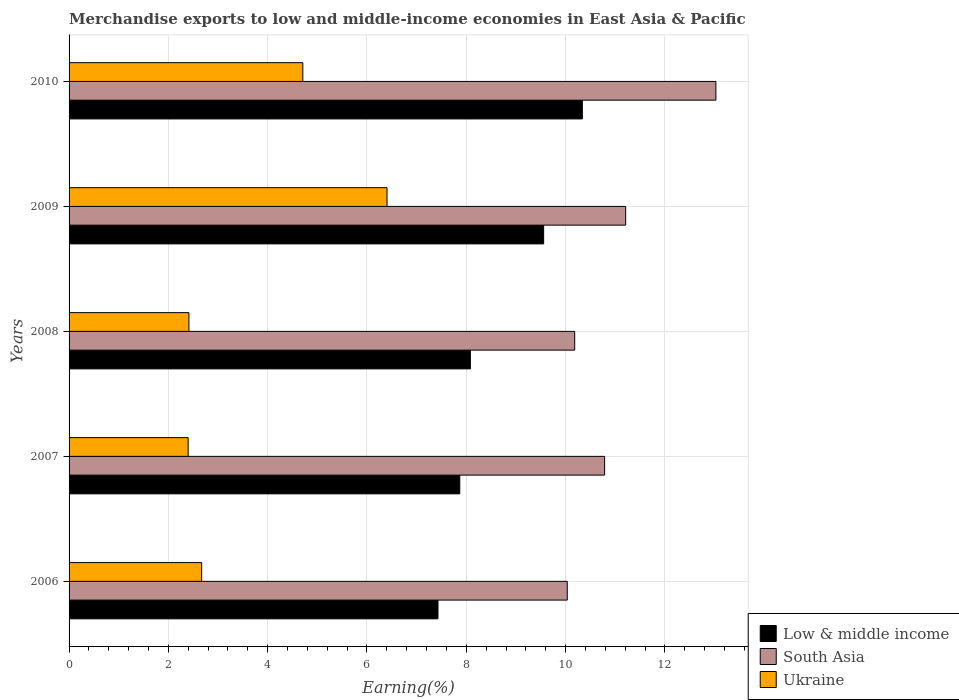How many different coloured bars are there?
Offer a terse response. 3. Are the number of bars per tick equal to the number of legend labels?
Provide a short and direct response. Yes. Are the number of bars on each tick of the Y-axis equal?
Offer a terse response. Yes. How many bars are there on the 4th tick from the top?
Ensure brevity in your answer.  3. In how many cases, is the number of bars for a given year not equal to the number of legend labels?
Offer a very short reply. 0. What is the percentage of amount earned from merchandise exports in Low & middle income in 2007?
Your answer should be compact. 7.87. Across all years, what is the maximum percentage of amount earned from merchandise exports in Low & middle income?
Offer a terse response. 10.34. Across all years, what is the minimum percentage of amount earned from merchandise exports in Ukraine?
Offer a terse response. 2.4. In which year was the percentage of amount earned from merchandise exports in Ukraine minimum?
Give a very brief answer. 2007. What is the total percentage of amount earned from merchandise exports in Low & middle income in the graph?
Give a very brief answer. 43.28. What is the difference between the percentage of amount earned from merchandise exports in Ukraine in 2007 and that in 2010?
Offer a very short reply. -2.31. What is the difference between the percentage of amount earned from merchandise exports in Ukraine in 2009 and the percentage of amount earned from merchandise exports in Low & middle income in 2008?
Offer a terse response. -1.68. What is the average percentage of amount earned from merchandise exports in Low & middle income per year?
Offer a terse response. 8.66. In the year 2008, what is the difference between the percentage of amount earned from merchandise exports in Ukraine and percentage of amount earned from merchandise exports in Low & middle income?
Provide a succinct answer. -5.67. What is the ratio of the percentage of amount earned from merchandise exports in Low & middle income in 2007 to that in 2009?
Provide a succinct answer. 0.82. What is the difference between the highest and the second highest percentage of amount earned from merchandise exports in Low & middle income?
Give a very brief answer. 0.78. What is the difference between the highest and the lowest percentage of amount earned from merchandise exports in South Asia?
Your answer should be very brief. 2.99. In how many years, is the percentage of amount earned from merchandise exports in Low & middle income greater than the average percentage of amount earned from merchandise exports in Low & middle income taken over all years?
Provide a succinct answer. 2. Is the sum of the percentage of amount earned from merchandise exports in Low & middle income in 2006 and 2009 greater than the maximum percentage of amount earned from merchandise exports in South Asia across all years?
Provide a succinct answer. Yes. What does the 2nd bar from the bottom in 2006 represents?
Give a very brief answer. South Asia. Is it the case that in every year, the sum of the percentage of amount earned from merchandise exports in South Asia and percentage of amount earned from merchandise exports in Ukraine is greater than the percentage of amount earned from merchandise exports in Low & middle income?
Give a very brief answer. Yes. How many years are there in the graph?
Provide a short and direct response. 5. Are the values on the major ticks of X-axis written in scientific E-notation?
Offer a terse response. No. Where does the legend appear in the graph?
Provide a succinct answer. Bottom right. How many legend labels are there?
Give a very brief answer. 3. What is the title of the graph?
Keep it short and to the point. Merchandise exports to low and middle-income economies in East Asia & Pacific. What is the label or title of the X-axis?
Offer a terse response. Earning(%). What is the Earning(%) in Low & middle income in 2006?
Ensure brevity in your answer.  7.43. What is the Earning(%) in South Asia in 2006?
Provide a succinct answer. 10.03. What is the Earning(%) of Ukraine in 2006?
Offer a terse response. 2.67. What is the Earning(%) in Low & middle income in 2007?
Provide a short and direct response. 7.87. What is the Earning(%) in South Asia in 2007?
Provide a short and direct response. 10.79. What is the Earning(%) of Ukraine in 2007?
Provide a short and direct response. 2.4. What is the Earning(%) of Low & middle income in 2008?
Provide a short and direct response. 8.08. What is the Earning(%) in South Asia in 2008?
Give a very brief answer. 10.18. What is the Earning(%) in Ukraine in 2008?
Your response must be concise. 2.41. What is the Earning(%) of Low & middle income in 2009?
Provide a short and direct response. 9.56. What is the Earning(%) in South Asia in 2009?
Ensure brevity in your answer.  11.21. What is the Earning(%) of Ukraine in 2009?
Your response must be concise. 6.4. What is the Earning(%) of Low & middle income in 2010?
Provide a short and direct response. 10.34. What is the Earning(%) of South Asia in 2010?
Offer a very short reply. 13.03. What is the Earning(%) in Ukraine in 2010?
Provide a succinct answer. 4.71. Across all years, what is the maximum Earning(%) of Low & middle income?
Provide a short and direct response. 10.34. Across all years, what is the maximum Earning(%) in South Asia?
Provide a short and direct response. 13.03. Across all years, what is the maximum Earning(%) in Ukraine?
Give a very brief answer. 6.4. Across all years, what is the minimum Earning(%) in Low & middle income?
Your answer should be compact. 7.43. Across all years, what is the minimum Earning(%) of South Asia?
Give a very brief answer. 10.03. Across all years, what is the minimum Earning(%) in Ukraine?
Offer a terse response. 2.4. What is the total Earning(%) in Low & middle income in the graph?
Ensure brevity in your answer.  43.28. What is the total Earning(%) of South Asia in the graph?
Offer a terse response. 55.24. What is the total Earning(%) of Ukraine in the graph?
Keep it short and to the point. 18.59. What is the difference between the Earning(%) in Low & middle income in 2006 and that in 2007?
Ensure brevity in your answer.  -0.44. What is the difference between the Earning(%) of South Asia in 2006 and that in 2007?
Your answer should be compact. -0.75. What is the difference between the Earning(%) of Ukraine in 2006 and that in 2007?
Give a very brief answer. 0.27. What is the difference between the Earning(%) in Low & middle income in 2006 and that in 2008?
Offer a very short reply. -0.65. What is the difference between the Earning(%) in South Asia in 2006 and that in 2008?
Offer a very short reply. -0.15. What is the difference between the Earning(%) in Ukraine in 2006 and that in 2008?
Your response must be concise. 0.26. What is the difference between the Earning(%) in Low & middle income in 2006 and that in 2009?
Your answer should be compact. -2.13. What is the difference between the Earning(%) of South Asia in 2006 and that in 2009?
Provide a short and direct response. -1.18. What is the difference between the Earning(%) of Ukraine in 2006 and that in 2009?
Your response must be concise. -3.73. What is the difference between the Earning(%) of Low & middle income in 2006 and that in 2010?
Offer a terse response. -2.91. What is the difference between the Earning(%) in South Asia in 2006 and that in 2010?
Ensure brevity in your answer.  -2.99. What is the difference between the Earning(%) of Ukraine in 2006 and that in 2010?
Provide a succinct answer. -2.04. What is the difference between the Earning(%) in Low & middle income in 2007 and that in 2008?
Your answer should be compact. -0.21. What is the difference between the Earning(%) of South Asia in 2007 and that in 2008?
Offer a very short reply. 0.6. What is the difference between the Earning(%) of Ukraine in 2007 and that in 2008?
Offer a terse response. -0.02. What is the difference between the Earning(%) in Low & middle income in 2007 and that in 2009?
Offer a very short reply. -1.69. What is the difference between the Earning(%) of South Asia in 2007 and that in 2009?
Provide a short and direct response. -0.42. What is the difference between the Earning(%) of Ukraine in 2007 and that in 2009?
Your answer should be very brief. -4.01. What is the difference between the Earning(%) of Low & middle income in 2007 and that in 2010?
Provide a succinct answer. -2.47. What is the difference between the Earning(%) in South Asia in 2007 and that in 2010?
Keep it short and to the point. -2.24. What is the difference between the Earning(%) of Ukraine in 2007 and that in 2010?
Ensure brevity in your answer.  -2.31. What is the difference between the Earning(%) in Low & middle income in 2008 and that in 2009?
Keep it short and to the point. -1.48. What is the difference between the Earning(%) of South Asia in 2008 and that in 2009?
Give a very brief answer. -1.03. What is the difference between the Earning(%) of Ukraine in 2008 and that in 2009?
Offer a terse response. -3.99. What is the difference between the Earning(%) in Low & middle income in 2008 and that in 2010?
Offer a very short reply. -2.26. What is the difference between the Earning(%) in South Asia in 2008 and that in 2010?
Give a very brief answer. -2.84. What is the difference between the Earning(%) of Ukraine in 2008 and that in 2010?
Offer a very short reply. -2.29. What is the difference between the Earning(%) of Low & middle income in 2009 and that in 2010?
Provide a short and direct response. -0.78. What is the difference between the Earning(%) of South Asia in 2009 and that in 2010?
Offer a terse response. -1.82. What is the difference between the Earning(%) of Ukraine in 2009 and that in 2010?
Ensure brevity in your answer.  1.7. What is the difference between the Earning(%) of Low & middle income in 2006 and the Earning(%) of South Asia in 2007?
Your answer should be very brief. -3.36. What is the difference between the Earning(%) in Low & middle income in 2006 and the Earning(%) in Ukraine in 2007?
Keep it short and to the point. 5.03. What is the difference between the Earning(%) of South Asia in 2006 and the Earning(%) of Ukraine in 2007?
Your answer should be very brief. 7.64. What is the difference between the Earning(%) in Low & middle income in 2006 and the Earning(%) in South Asia in 2008?
Provide a succinct answer. -2.75. What is the difference between the Earning(%) of Low & middle income in 2006 and the Earning(%) of Ukraine in 2008?
Offer a terse response. 5.02. What is the difference between the Earning(%) of South Asia in 2006 and the Earning(%) of Ukraine in 2008?
Provide a short and direct response. 7.62. What is the difference between the Earning(%) in Low & middle income in 2006 and the Earning(%) in South Asia in 2009?
Your response must be concise. -3.78. What is the difference between the Earning(%) of Low & middle income in 2006 and the Earning(%) of Ukraine in 2009?
Offer a very short reply. 1.03. What is the difference between the Earning(%) of South Asia in 2006 and the Earning(%) of Ukraine in 2009?
Your answer should be compact. 3.63. What is the difference between the Earning(%) in Low & middle income in 2006 and the Earning(%) in South Asia in 2010?
Ensure brevity in your answer.  -5.6. What is the difference between the Earning(%) in Low & middle income in 2006 and the Earning(%) in Ukraine in 2010?
Make the answer very short. 2.72. What is the difference between the Earning(%) in South Asia in 2006 and the Earning(%) in Ukraine in 2010?
Keep it short and to the point. 5.33. What is the difference between the Earning(%) in Low & middle income in 2007 and the Earning(%) in South Asia in 2008?
Ensure brevity in your answer.  -2.31. What is the difference between the Earning(%) in Low & middle income in 2007 and the Earning(%) in Ukraine in 2008?
Provide a short and direct response. 5.45. What is the difference between the Earning(%) in South Asia in 2007 and the Earning(%) in Ukraine in 2008?
Keep it short and to the point. 8.37. What is the difference between the Earning(%) of Low & middle income in 2007 and the Earning(%) of South Asia in 2009?
Give a very brief answer. -3.34. What is the difference between the Earning(%) of Low & middle income in 2007 and the Earning(%) of Ukraine in 2009?
Ensure brevity in your answer.  1.47. What is the difference between the Earning(%) in South Asia in 2007 and the Earning(%) in Ukraine in 2009?
Provide a short and direct response. 4.38. What is the difference between the Earning(%) of Low & middle income in 2007 and the Earning(%) of South Asia in 2010?
Offer a very short reply. -5.16. What is the difference between the Earning(%) in Low & middle income in 2007 and the Earning(%) in Ukraine in 2010?
Your response must be concise. 3.16. What is the difference between the Earning(%) in South Asia in 2007 and the Earning(%) in Ukraine in 2010?
Keep it short and to the point. 6.08. What is the difference between the Earning(%) of Low & middle income in 2008 and the Earning(%) of South Asia in 2009?
Give a very brief answer. -3.13. What is the difference between the Earning(%) in Low & middle income in 2008 and the Earning(%) in Ukraine in 2009?
Offer a very short reply. 1.68. What is the difference between the Earning(%) in South Asia in 2008 and the Earning(%) in Ukraine in 2009?
Your answer should be compact. 3.78. What is the difference between the Earning(%) in Low & middle income in 2008 and the Earning(%) in South Asia in 2010?
Keep it short and to the point. -4.94. What is the difference between the Earning(%) of Low & middle income in 2008 and the Earning(%) of Ukraine in 2010?
Your answer should be compact. 3.37. What is the difference between the Earning(%) in South Asia in 2008 and the Earning(%) in Ukraine in 2010?
Your response must be concise. 5.48. What is the difference between the Earning(%) in Low & middle income in 2009 and the Earning(%) in South Asia in 2010?
Offer a terse response. -3.47. What is the difference between the Earning(%) of Low & middle income in 2009 and the Earning(%) of Ukraine in 2010?
Provide a succinct answer. 4.85. What is the difference between the Earning(%) in South Asia in 2009 and the Earning(%) in Ukraine in 2010?
Make the answer very short. 6.5. What is the average Earning(%) in Low & middle income per year?
Offer a terse response. 8.66. What is the average Earning(%) in South Asia per year?
Your response must be concise. 11.05. What is the average Earning(%) in Ukraine per year?
Make the answer very short. 3.72. In the year 2006, what is the difference between the Earning(%) of Low & middle income and Earning(%) of South Asia?
Your answer should be compact. -2.6. In the year 2006, what is the difference between the Earning(%) in Low & middle income and Earning(%) in Ukraine?
Provide a short and direct response. 4.76. In the year 2006, what is the difference between the Earning(%) of South Asia and Earning(%) of Ukraine?
Your answer should be compact. 7.36. In the year 2007, what is the difference between the Earning(%) of Low & middle income and Earning(%) of South Asia?
Offer a terse response. -2.92. In the year 2007, what is the difference between the Earning(%) in Low & middle income and Earning(%) in Ukraine?
Your answer should be compact. 5.47. In the year 2007, what is the difference between the Earning(%) of South Asia and Earning(%) of Ukraine?
Your answer should be very brief. 8.39. In the year 2008, what is the difference between the Earning(%) of Low & middle income and Earning(%) of South Asia?
Offer a terse response. -2.1. In the year 2008, what is the difference between the Earning(%) in Low & middle income and Earning(%) in Ukraine?
Give a very brief answer. 5.67. In the year 2008, what is the difference between the Earning(%) of South Asia and Earning(%) of Ukraine?
Ensure brevity in your answer.  7.77. In the year 2009, what is the difference between the Earning(%) in Low & middle income and Earning(%) in South Asia?
Your answer should be compact. -1.65. In the year 2009, what is the difference between the Earning(%) of Low & middle income and Earning(%) of Ukraine?
Give a very brief answer. 3.15. In the year 2009, what is the difference between the Earning(%) of South Asia and Earning(%) of Ukraine?
Give a very brief answer. 4.81. In the year 2010, what is the difference between the Earning(%) of Low & middle income and Earning(%) of South Asia?
Ensure brevity in your answer.  -2.69. In the year 2010, what is the difference between the Earning(%) of Low & middle income and Earning(%) of Ukraine?
Make the answer very short. 5.63. In the year 2010, what is the difference between the Earning(%) of South Asia and Earning(%) of Ukraine?
Your response must be concise. 8.32. What is the ratio of the Earning(%) in Low & middle income in 2006 to that in 2007?
Offer a terse response. 0.94. What is the ratio of the Earning(%) in South Asia in 2006 to that in 2007?
Offer a terse response. 0.93. What is the ratio of the Earning(%) in Ukraine in 2006 to that in 2007?
Your answer should be compact. 1.11. What is the ratio of the Earning(%) of Low & middle income in 2006 to that in 2008?
Ensure brevity in your answer.  0.92. What is the ratio of the Earning(%) of Ukraine in 2006 to that in 2008?
Give a very brief answer. 1.11. What is the ratio of the Earning(%) in Low & middle income in 2006 to that in 2009?
Make the answer very short. 0.78. What is the ratio of the Earning(%) in South Asia in 2006 to that in 2009?
Keep it short and to the point. 0.9. What is the ratio of the Earning(%) in Ukraine in 2006 to that in 2009?
Your answer should be compact. 0.42. What is the ratio of the Earning(%) of Low & middle income in 2006 to that in 2010?
Make the answer very short. 0.72. What is the ratio of the Earning(%) of South Asia in 2006 to that in 2010?
Offer a very short reply. 0.77. What is the ratio of the Earning(%) in Ukraine in 2006 to that in 2010?
Make the answer very short. 0.57. What is the ratio of the Earning(%) of Low & middle income in 2007 to that in 2008?
Your answer should be compact. 0.97. What is the ratio of the Earning(%) in South Asia in 2007 to that in 2008?
Provide a short and direct response. 1.06. What is the ratio of the Earning(%) of Ukraine in 2007 to that in 2008?
Give a very brief answer. 0.99. What is the ratio of the Earning(%) of Low & middle income in 2007 to that in 2009?
Your answer should be very brief. 0.82. What is the ratio of the Earning(%) of South Asia in 2007 to that in 2009?
Keep it short and to the point. 0.96. What is the ratio of the Earning(%) of Ukraine in 2007 to that in 2009?
Provide a succinct answer. 0.37. What is the ratio of the Earning(%) of Low & middle income in 2007 to that in 2010?
Provide a succinct answer. 0.76. What is the ratio of the Earning(%) of South Asia in 2007 to that in 2010?
Offer a very short reply. 0.83. What is the ratio of the Earning(%) of Ukraine in 2007 to that in 2010?
Ensure brevity in your answer.  0.51. What is the ratio of the Earning(%) in Low & middle income in 2008 to that in 2009?
Your answer should be compact. 0.85. What is the ratio of the Earning(%) of South Asia in 2008 to that in 2009?
Keep it short and to the point. 0.91. What is the ratio of the Earning(%) of Ukraine in 2008 to that in 2009?
Give a very brief answer. 0.38. What is the ratio of the Earning(%) of Low & middle income in 2008 to that in 2010?
Ensure brevity in your answer.  0.78. What is the ratio of the Earning(%) of South Asia in 2008 to that in 2010?
Offer a very short reply. 0.78. What is the ratio of the Earning(%) of Ukraine in 2008 to that in 2010?
Ensure brevity in your answer.  0.51. What is the ratio of the Earning(%) of Low & middle income in 2009 to that in 2010?
Your answer should be compact. 0.92. What is the ratio of the Earning(%) of South Asia in 2009 to that in 2010?
Keep it short and to the point. 0.86. What is the ratio of the Earning(%) in Ukraine in 2009 to that in 2010?
Keep it short and to the point. 1.36. What is the difference between the highest and the second highest Earning(%) in Low & middle income?
Your answer should be compact. 0.78. What is the difference between the highest and the second highest Earning(%) in South Asia?
Give a very brief answer. 1.82. What is the difference between the highest and the second highest Earning(%) in Ukraine?
Ensure brevity in your answer.  1.7. What is the difference between the highest and the lowest Earning(%) in Low & middle income?
Offer a very short reply. 2.91. What is the difference between the highest and the lowest Earning(%) of South Asia?
Your answer should be very brief. 2.99. What is the difference between the highest and the lowest Earning(%) in Ukraine?
Keep it short and to the point. 4.01. 